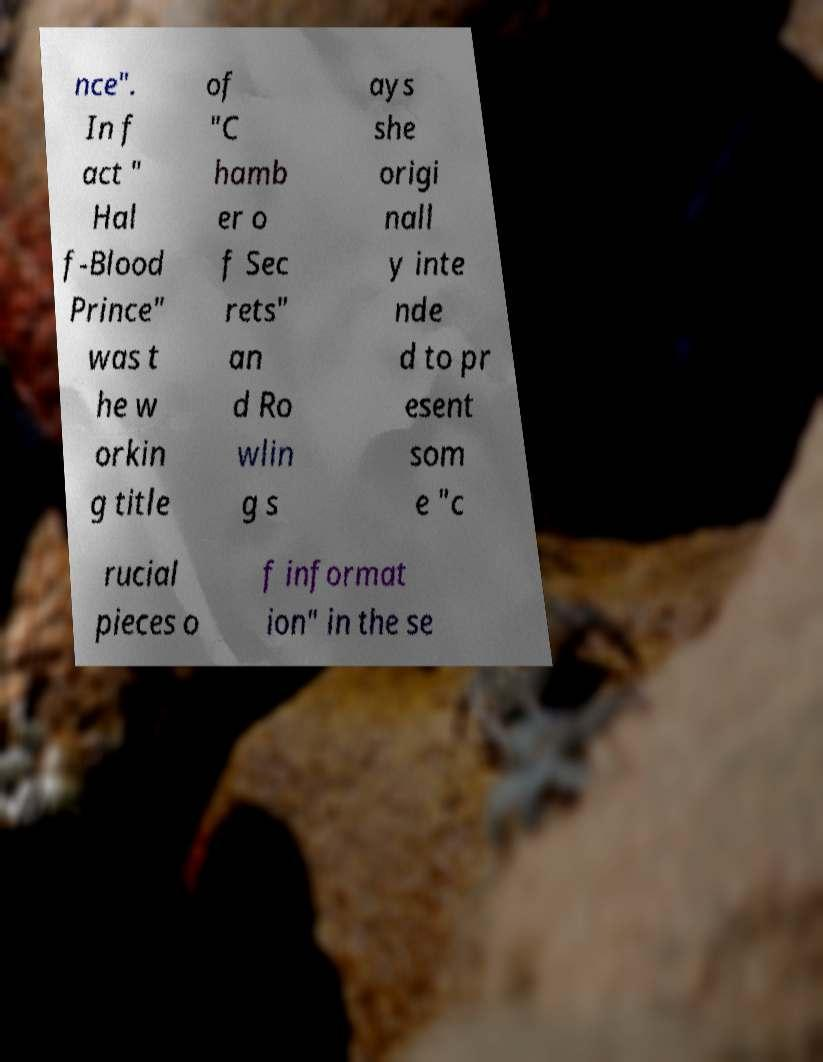Could you extract and type out the text from this image? nce". In f act " Hal f-Blood Prince" was t he w orkin g title of "C hamb er o f Sec rets" an d Ro wlin g s ays she origi nall y inte nde d to pr esent som e "c rucial pieces o f informat ion" in the se 